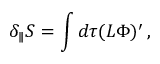<formula> <loc_0><loc_0><loc_500><loc_500>\delta _ { \| } S = \int d \tau ( L \Phi ) ^ { \prime } \, ,</formula> 